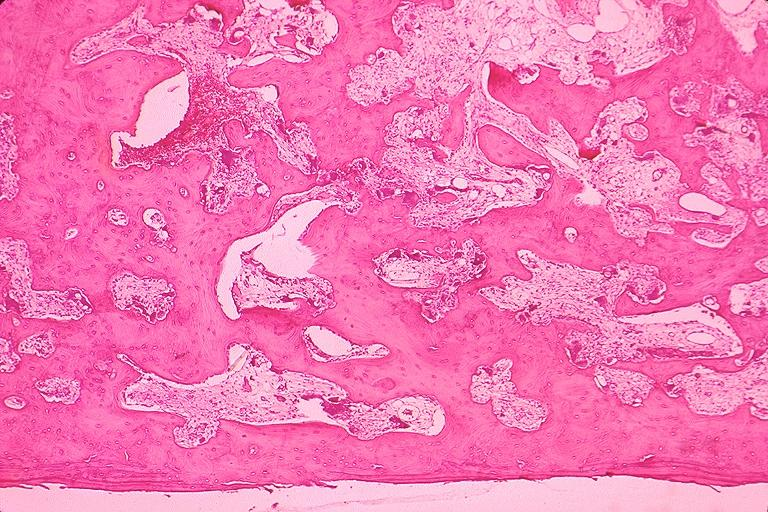s serous cyst present?
Answer the question using a single word or phrase. No 